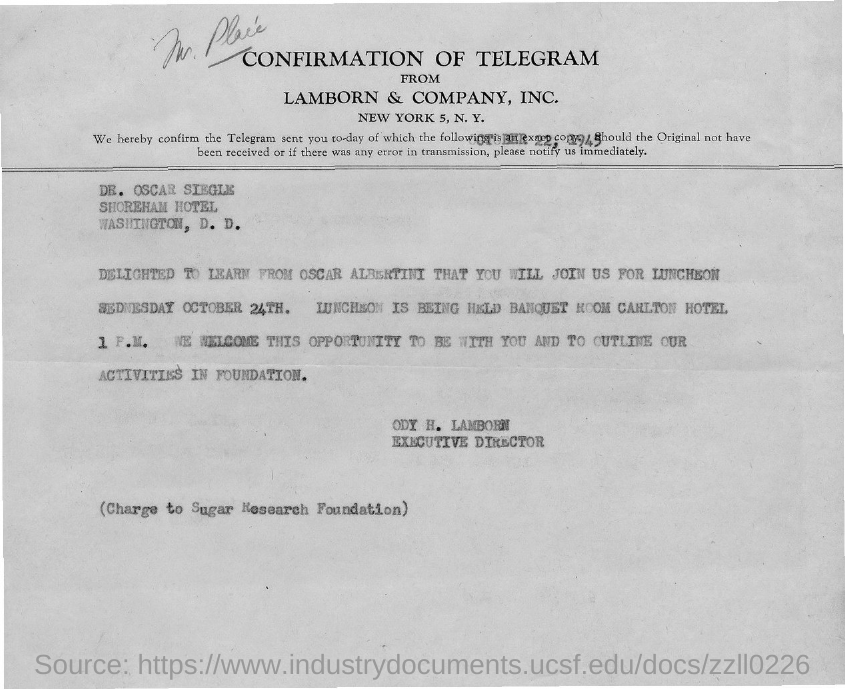Who is the sender of this confirmation?
Ensure brevity in your answer.  ODY H. LAMBORN. To whom, the confirmation is sent?
Ensure brevity in your answer.  DR. OSCAR SIEGLE. What is the designation of ODY H. LAMBORN?
Keep it short and to the point. EXECUTIVE DIRECTOR. 